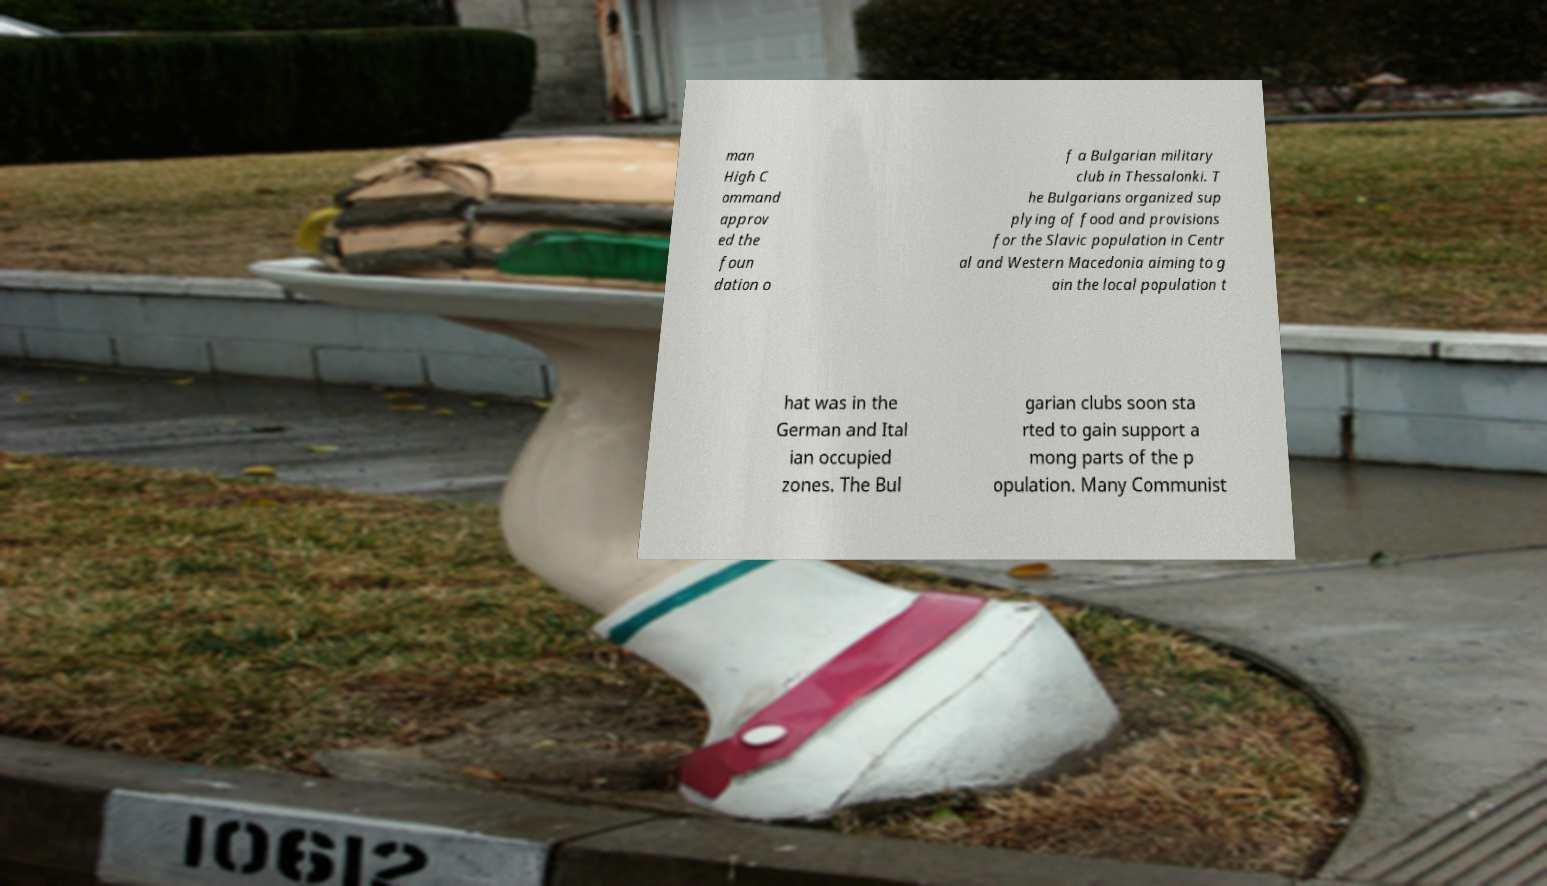Can you read and provide the text displayed in the image?This photo seems to have some interesting text. Can you extract and type it out for me? man High C ommand approv ed the foun dation o f a Bulgarian military club in Thessalonki. T he Bulgarians organized sup plying of food and provisions for the Slavic population in Centr al and Western Macedonia aiming to g ain the local population t hat was in the German and Ital ian occupied zones. The Bul garian clubs soon sta rted to gain support a mong parts of the p opulation. Many Communist 